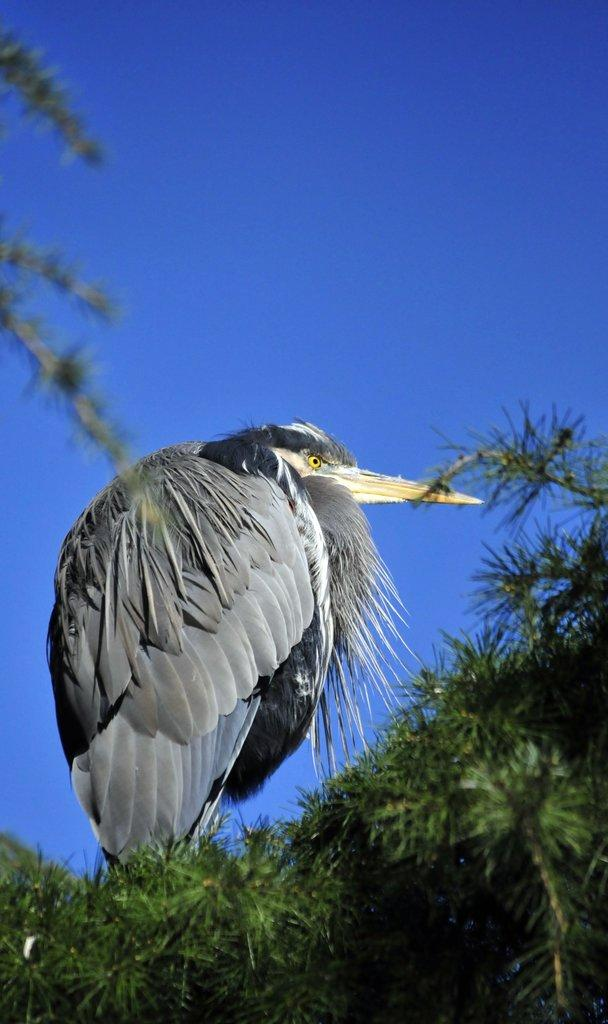What is the main subject in the front of the image? There is a bird in the front of the image. What else can be seen in the front of the image besides the bird? There is greenery in the front of the image. What is visible in the background of the image? The sky is visible in the background of the image. How many feathers can be seen bursting from the bird in the image? There is no indication in the image that any feathers are bursting from the bird. 